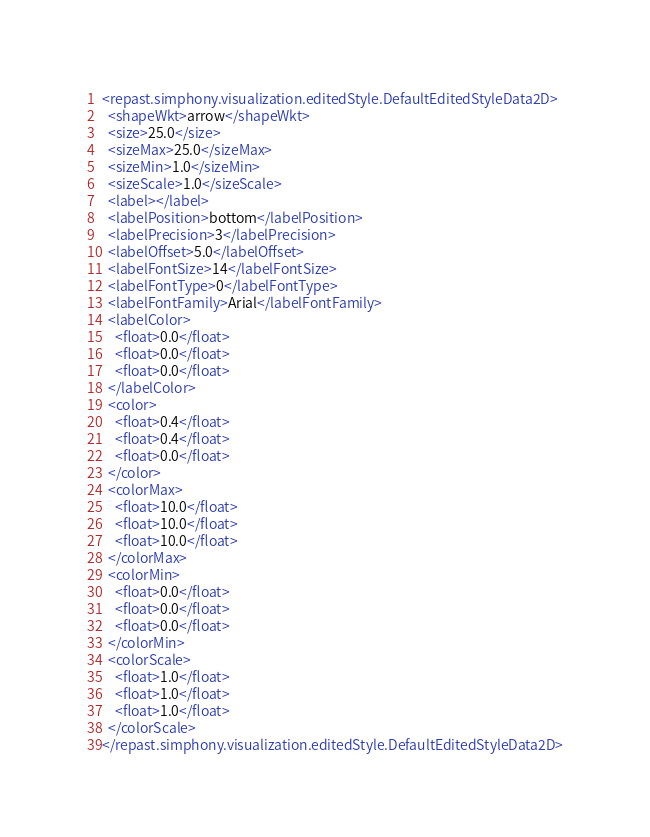<code> <loc_0><loc_0><loc_500><loc_500><_XML_><repast.simphony.visualization.editedStyle.DefaultEditedStyleData2D>
  <shapeWkt>arrow</shapeWkt>
  <size>25.0</size>
  <sizeMax>25.0</sizeMax>
  <sizeMin>1.0</sizeMin>
  <sizeScale>1.0</sizeScale>
  <label></label>
  <labelPosition>bottom</labelPosition>
  <labelPrecision>3</labelPrecision>
  <labelOffset>5.0</labelOffset>
  <labelFontSize>14</labelFontSize>
  <labelFontType>0</labelFontType>
  <labelFontFamily>Arial</labelFontFamily>
  <labelColor>
    <float>0.0</float>
    <float>0.0</float>
    <float>0.0</float>
  </labelColor>
  <color>
    <float>0.4</float>
    <float>0.4</float>
    <float>0.0</float>
  </color>
  <colorMax>
    <float>10.0</float>
    <float>10.0</float>
    <float>10.0</float>
  </colorMax>
  <colorMin>
    <float>0.0</float>
    <float>0.0</float>
    <float>0.0</float>
  </colorMin>
  <colorScale>
    <float>1.0</float>
    <float>1.0</float>
    <float>1.0</float>
  </colorScale>
</repast.simphony.visualization.editedStyle.DefaultEditedStyleData2D></code> 